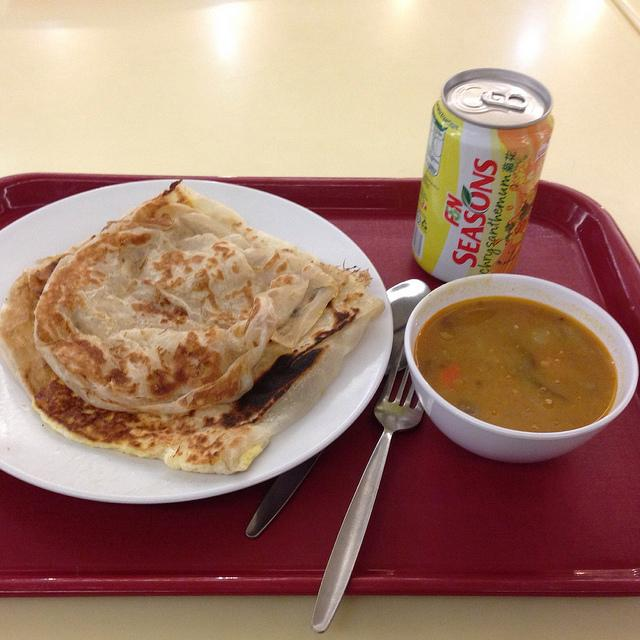Which item is probably the coldest?

Choices:
A) can
B) plate
C) bowl
D) tray can 